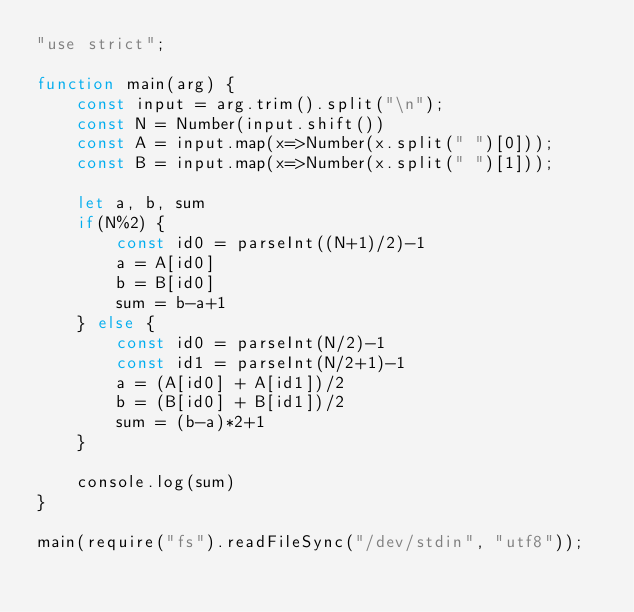Convert code to text. <code><loc_0><loc_0><loc_500><loc_500><_JavaScript_>"use strict";

function main(arg) {
    const input = arg.trim().split("\n");
    const N = Number(input.shift())
    const A = input.map(x=>Number(x.split(" ")[0]));
    const B = input.map(x=>Number(x.split(" ")[1]));

    let a, b, sum
    if(N%2) {
        const id0 = parseInt((N+1)/2)-1
        a = A[id0]
        b = B[id0]
        sum = b-a+1
    } else {
        const id0 = parseInt(N/2)-1
        const id1 = parseInt(N/2+1)-1
        a = (A[id0] + A[id1])/2
        b = (B[id0] + B[id1])/2
        sum = (b-a)*2+1
    }

    console.log(sum)
}

main(require("fs").readFileSync("/dev/stdin", "utf8"));</code> 